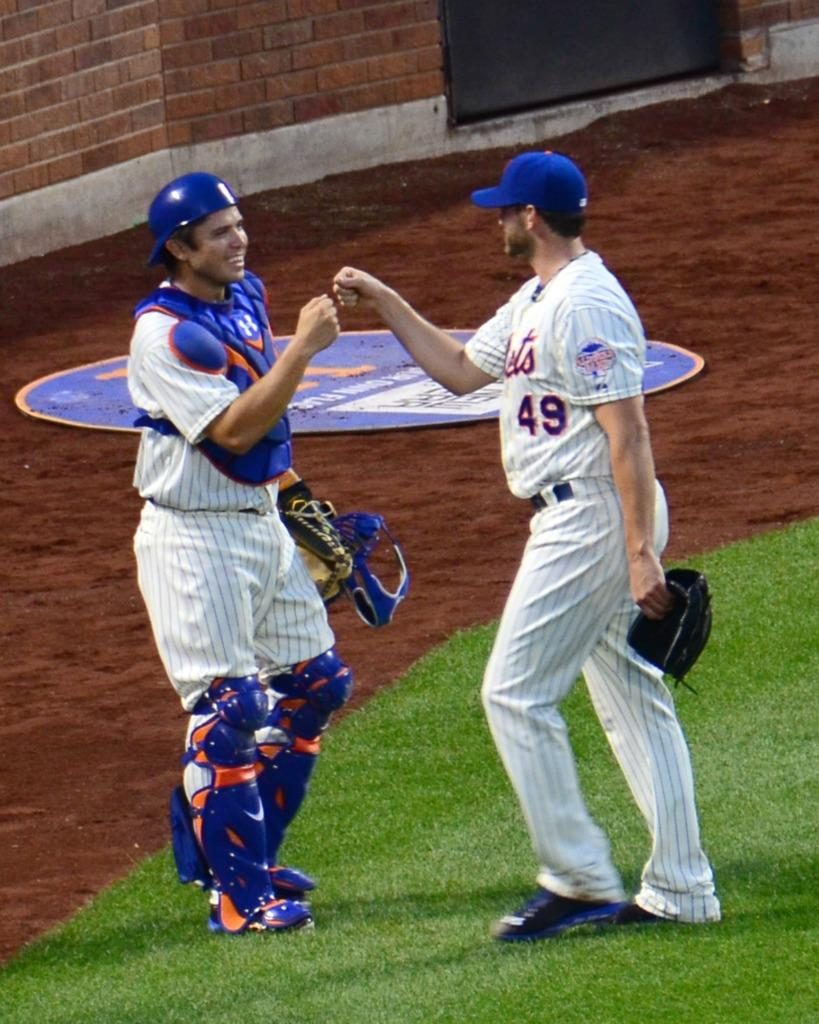<image>
Share a concise interpretation of the image provided. the number 49 player for the Mets congratulating another 